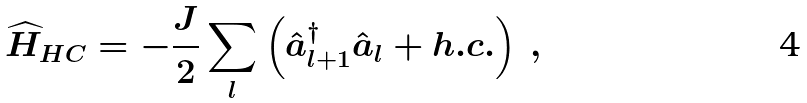<formula> <loc_0><loc_0><loc_500><loc_500>\widehat { H } _ { H C } = - \frac { J } { 2 } \sum _ { l } \left ( \hat { a } ^ { \dag } _ { l + 1 } \hat { a } _ { l } + h . c . \right ) \, ,</formula> 